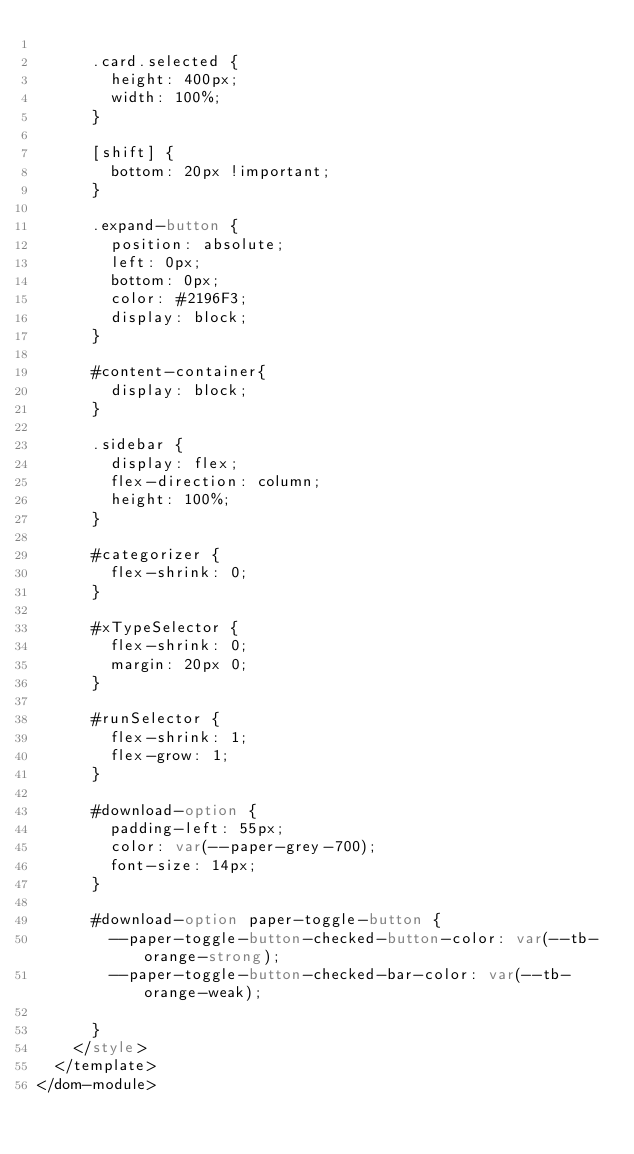Convert code to text. <code><loc_0><loc_0><loc_500><loc_500><_HTML_>
      .card.selected {
        height: 400px;
        width: 100%;
      }

      [shift] {
        bottom: 20px !important;
      }

      .expand-button {
        position: absolute;
        left: 0px;
        bottom: 0px;
        color: #2196F3;
        display: block;
      }

      #content-container{
        display: block;
      }

      .sidebar {
        display: flex;
        flex-direction: column;
        height: 100%;
      }

      #categorizer {
        flex-shrink: 0;
      }

      #xTypeSelector {
        flex-shrink: 0;
        margin: 20px 0;
      }

      #runSelector {
        flex-shrink: 1;
        flex-grow: 1;
      }

      #download-option {
        padding-left: 55px;
        color: var(--paper-grey-700);
        font-size: 14px;
      }

      #download-option paper-toggle-button {
        --paper-toggle-button-checked-button-color: var(--tb-orange-strong);
        --paper-toggle-button-checked-bar-color: var(--tb-orange-weak);

      }
    </style>
  </template>
</dom-module>
</code> 